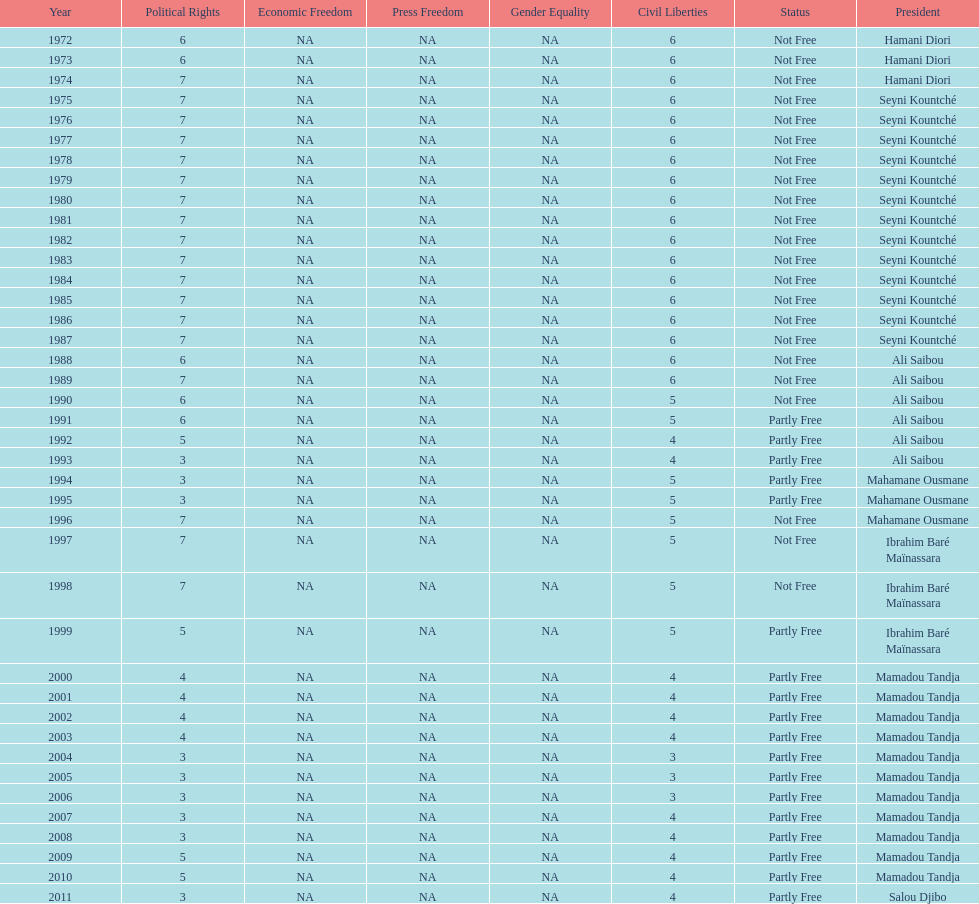How many times was the political rights listed as seven? 18. 